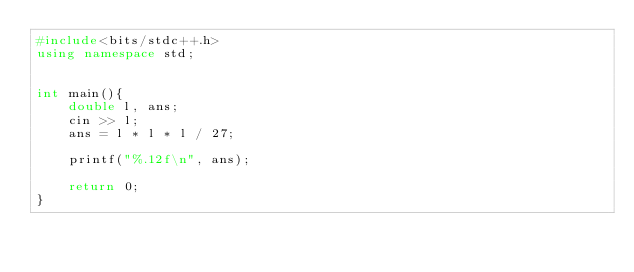<code> <loc_0><loc_0><loc_500><loc_500><_C++_>#include<bits/stdc++.h>
using namespace std;
                    
                    
int main(){
    double l, ans;
    cin >> l;
    ans = l * l * l / 27;

    printf("%.12f\n", ans);

    return 0;
}</code> 